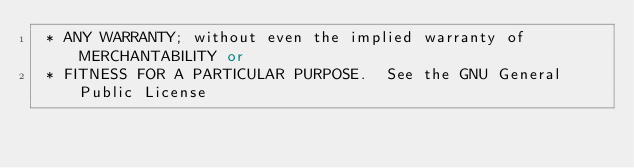<code> <loc_0><loc_0><loc_500><loc_500><_C++_> * ANY WARRANTY; without even the implied warranty of MERCHANTABILITY or
 * FITNESS FOR A PARTICULAR PURPOSE.  See the GNU General Public License</code> 